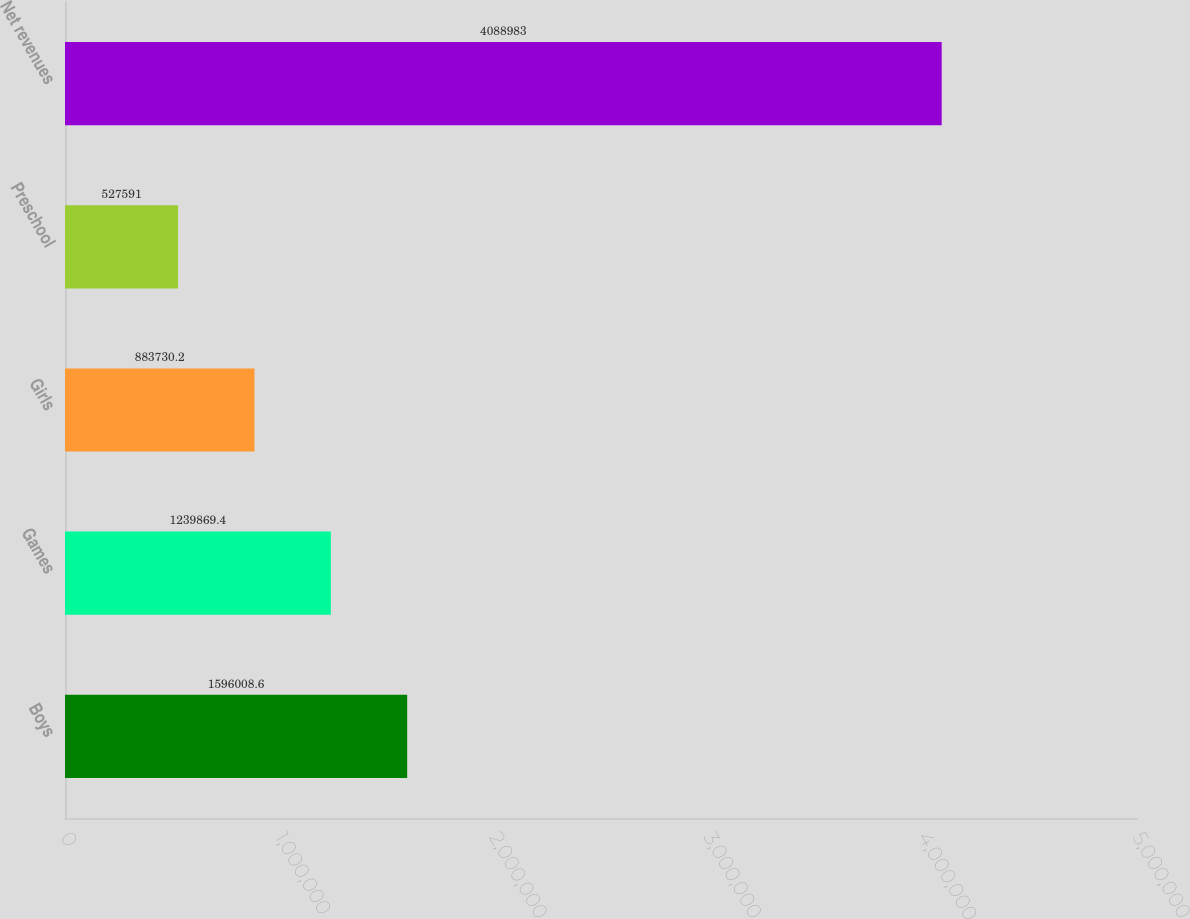<chart> <loc_0><loc_0><loc_500><loc_500><bar_chart><fcel>Boys<fcel>Games<fcel>Girls<fcel>Preschool<fcel>Net revenues<nl><fcel>1.59601e+06<fcel>1.23987e+06<fcel>883730<fcel>527591<fcel>4.08898e+06<nl></chart> 